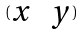Convert formula to latex. <formula><loc_0><loc_0><loc_500><loc_500>( \begin{matrix} x & y \end{matrix} )</formula> 